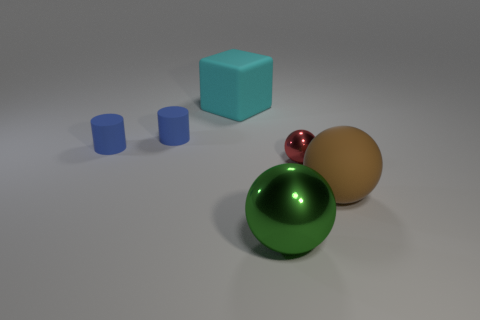Is there a blue rubber object that is behind the sphere that is to the left of the small object that is on the right side of the large green sphere?
Offer a very short reply. Yes. The large ball that is on the left side of the big matte thing that is in front of the large rubber cube is made of what material?
Your answer should be very brief. Metal. The ball that is both in front of the red ball and to the right of the big green shiny thing is made of what material?
Give a very brief answer. Rubber. Is there another metal object of the same shape as the tiny red metallic thing?
Provide a succinct answer. Yes. Are there any large cyan rubber things that are on the left side of the big object that is on the left side of the green object?
Your answer should be very brief. No. How many large green spheres have the same material as the cube?
Provide a succinct answer. 0. Are any big red shiny spheres visible?
Provide a succinct answer. No. How many shiny things are the same color as the large rubber sphere?
Provide a succinct answer. 0. Does the cyan thing have the same material as the sphere that is on the right side of the small metallic sphere?
Your answer should be compact. Yes. Is the number of small blue things that are behind the large brown sphere greater than the number of big spheres?
Your response must be concise. No. 